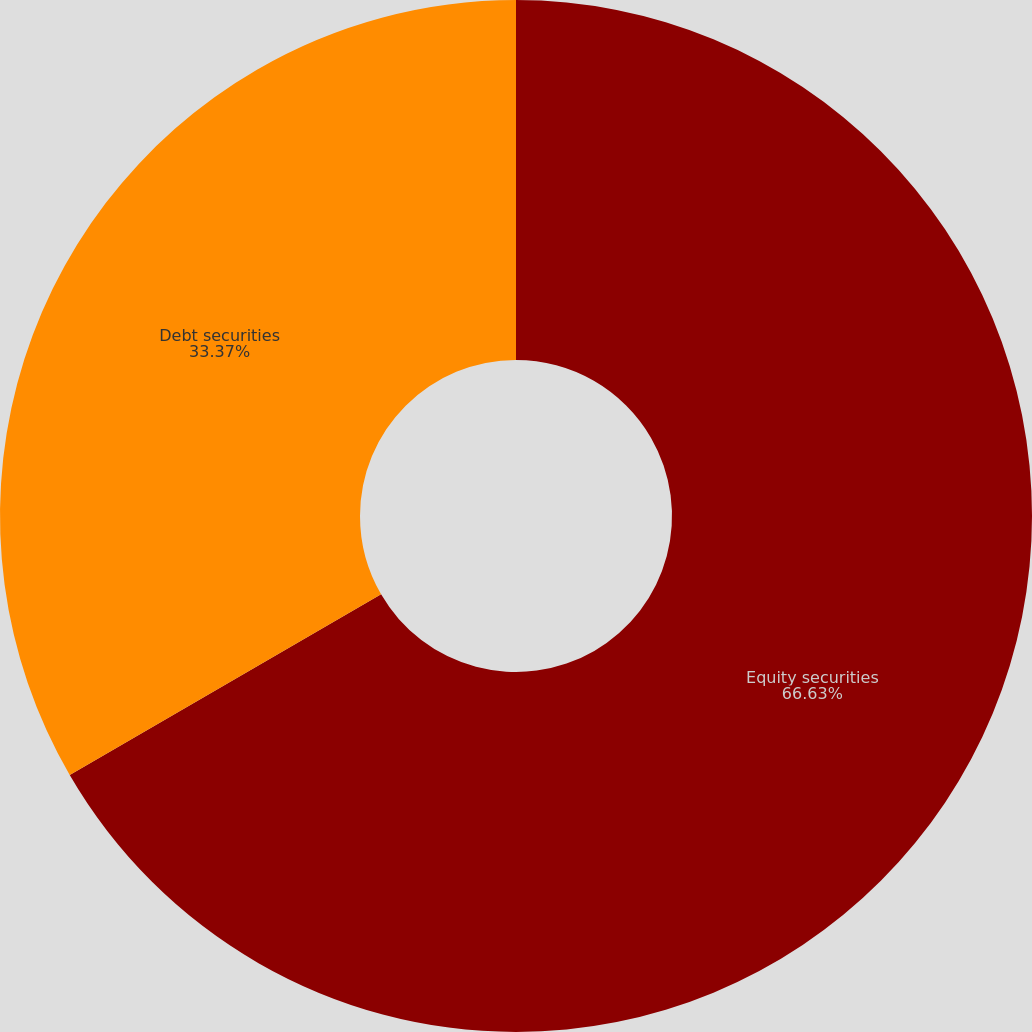<chart> <loc_0><loc_0><loc_500><loc_500><pie_chart><fcel>Equity securities<fcel>Debt securities<nl><fcel>66.63%<fcel>33.37%<nl></chart> 